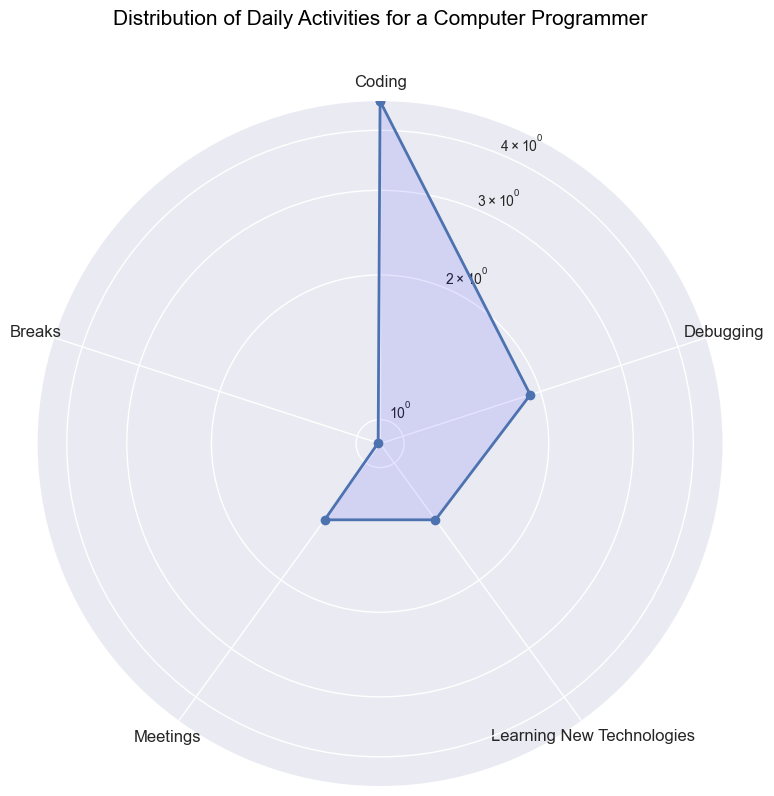What is the average amount of time spent on coding? To find the average time spent coding, sum the coding times (4 + 5 + 3 + 6 + 4 + 5 + 4 + 5 + 4 + 6) = 46, then divide by the number of days (10). The average is 46 / 10.
Answer: 4.6 Which activity is allocated the least amount of time on average? Look at the radar chart and identify the activity with the smallest average time. Since Breaks consistently have the lowest values among the activities, it’s the least allocated time.
Answer: Breaks Is the time spent on debugging greater than the time spent on meetings? Compare the average values of debugging and meetings on the radar chart. Debugging is generally around 2 on average, while meetings are around 1.5. So, debugging is greater.
Answer: Yes What’s the total time spent on learning new technologies over the 10 days? Sum the learning new technologies times (1 + 2 + 1 + 1 + 2 + 1 + 2 + 1 + 1 + 2) = 14.
Answer: 14 Which day had the highest amount of coding time? Reference the data or observe the radar chart’s coding points; Day 4 and Day 10 each have the highest coding time of 6 hours.
Answer: Day 4 and Day 10 How does the average time spent on breaks compare to debugging? Calculate the average break time (which involves adding the time for breaks, then dividing by 10): (2 + 1 + 1 + 1 + 0 + 1 + 1 + 0 + 1 + 1) = 9 / 10 = 0.9. For debugging, average is (2 + 1 + 3 + 2 + 2 + 1 + 1 + 2 + 3 + 2) = 19 / 10 = 1.9. Thus, breaks average is less than debugging.
Answer: Less What is the most consistent activity in terms of time spent daily? Evaluate the spread of data points for each activity on the radar chart. Meetings tend to show the least variation and hence is the most consistent in time allocation.
Answer: Meetings Among coding, debugging, and meetings, which has the highest peak value? Examine the highest points in the radar chart for the mentioned activities. Coding peaks at 6, debugging peaks at 3, and meetings peak at 2. Thus, coding has the highest peak.
Answer: Coding 